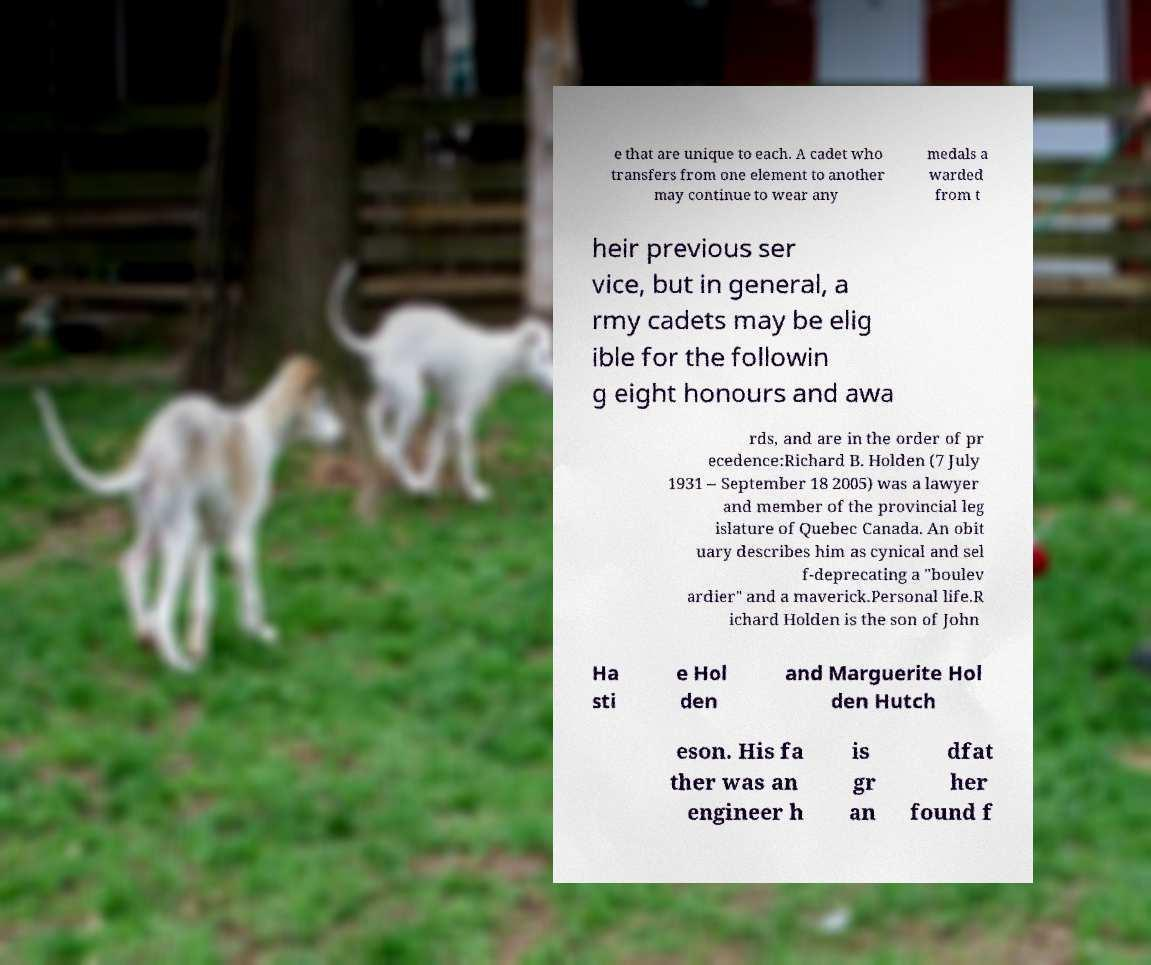Could you extract and type out the text from this image? e that are unique to each. A cadet who transfers from one element to another may continue to wear any medals a warded from t heir previous ser vice, but in general, a rmy cadets may be elig ible for the followin g eight honours and awa rds, and are in the order of pr ecedence:Richard B. Holden (7 July 1931 – September 18 2005) was a lawyer and member of the provincial leg islature of Quebec Canada. An obit uary describes him as cynical and sel f-deprecating a "boulev ardier" and a maverick.Personal life.R ichard Holden is the son of John Ha sti e Hol den and Marguerite Hol den Hutch eson. His fa ther was an engineer h is gr an dfat her found f 